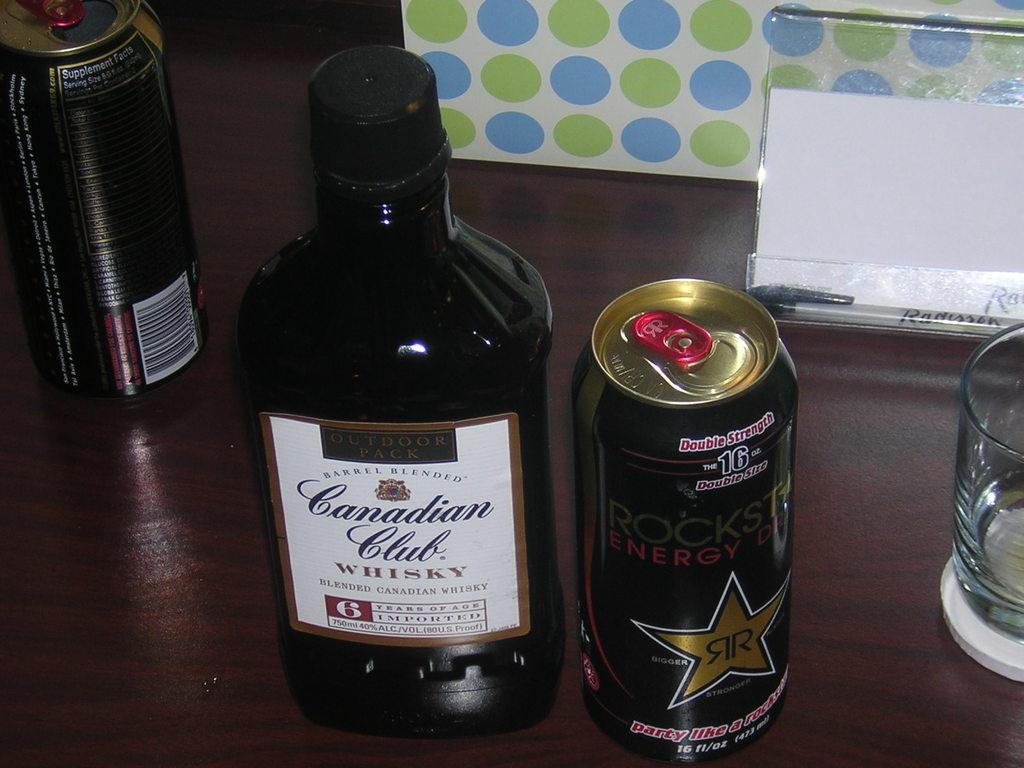Provide a one-sentence caption for the provided image. the words Canadian Club that are on a bottle. 